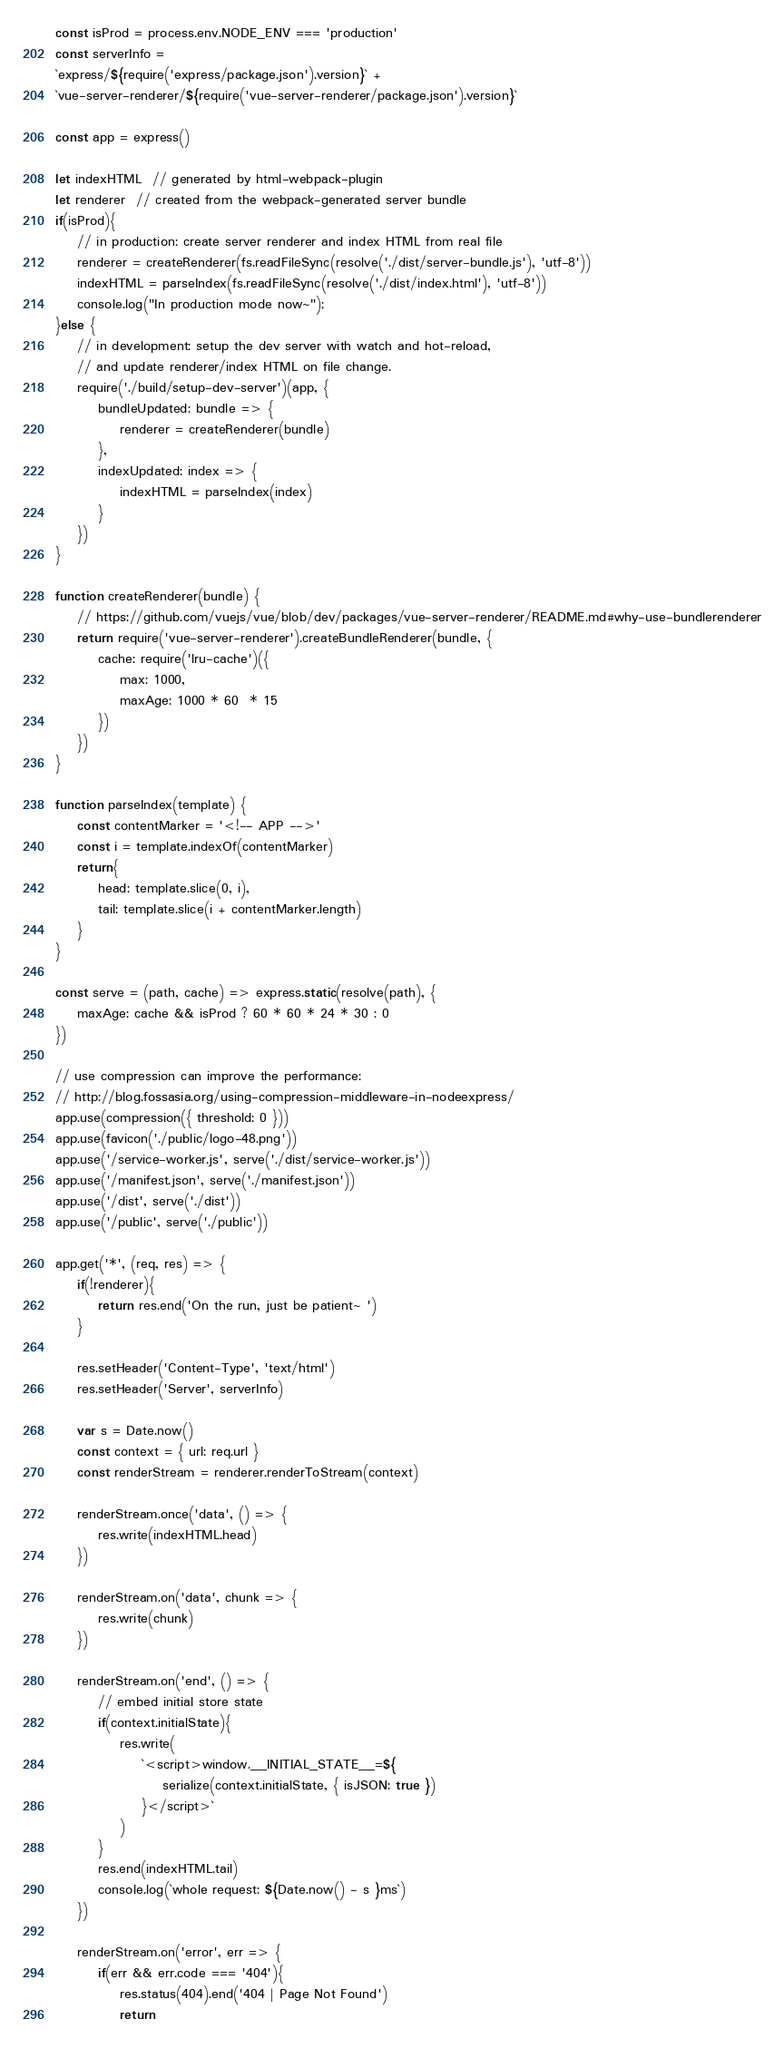Convert code to text. <code><loc_0><loc_0><loc_500><loc_500><_JavaScript_>const isProd = process.env.NODE_ENV === 'production'
const serverInfo =
`express/${require('express/package.json').version}` +
`vue-server-renderer/${require('vue-server-renderer/package.json').version}`

const app = express()

let indexHTML  // generated by html-webpack-plugin
let renderer  // created from the webpack-generated server bundle
if(isProd){
    // in production: create server renderer and index HTML from real file
    renderer = createRenderer(fs.readFileSync(resolve('./dist/server-bundle.js'), 'utf-8'))
    indexHTML = parseIndex(fs.readFileSync(resolve('./dist/index.html'), 'utf-8'))
    console.log("In production mode now~");
}else {
    // in development: setup the dev server with watch and hot-reload,
    // and update renderer/index HTML on file change.
    require('./build/setup-dev-server')(app, {
        bundleUpdated: bundle => {
            renderer = createRenderer(bundle)
        },
        indexUpdated: index => {
            indexHTML = parseIndex(index)
        }
    })
}

function createRenderer(bundle) {
    // https://github.com/vuejs/vue/blob/dev/packages/vue-server-renderer/README.md#why-use-bundlerenderer
    return require('vue-server-renderer').createBundleRenderer(bundle, {
        cache: require('lru-cache')({
            max: 1000,
            maxAge: 1000 * 60  * 15
        })
    })
}

function parseIndex(template) {
    const contentMarker = '<!-- APP -->'
    const i = template.indexOf(contentMarker)
    return{
        head: template.slice(0, i),
        tail: template.slice(i + contentMarker.length)
    }
}

const serve = (path, cache) => express.static(resolve(path), {
    maxAge: cache && isProd ? 60 * 60 * 24 * 30 : 0
})

// use compression can improve the performance:
// http://blog.fossasia.org/using-compression-middleware-in-nodeexpress/
app.use(compression({ threshold: 0 }))
app.use(favicon('./public/logo-48.png'))
app.use('/service-worker.js', serve('./dist/service-worker.js'))
app.use('/manifest.json', serve('./manifest.json'))
app.use('/dist', serve('./dist'))
app.use('/public', serve('./public'))

app.get('*', (req, res) => {
    if(!renderer){
        return res.end('On the run, just be patient~ ')
    }

    res.setHeader('Content-Type', 'text/html')
    res.setHeader('Server', serverInfo)

    var s = Date.now()
    const context = { url: req.url }
    const renderStream = renderer.renderToStream(context)

    renderStream.once('data', () => {
        res.write(indexHTML.head)
    })

    renderStream.on('data', chunk => {
        res.write(chunk)
    })

    renderStream.on('end', () => {
        // embed initial store state
        if(context.initialState){
            res.write(
                `<script>window.__INITIAL_STATE__=${
                    serialize(context.initialState, { isJSON: true })
                }</script>`
            )
        }
        res.end(indexHTML.tail)
        console.log(`whole request: ${Date.now() - s }ms`)
    })

    renderStream.on('error', err => {
        if(err && err.code === '404'){
            res.status(404).end('404 | Page Not Found')
            return</code> 